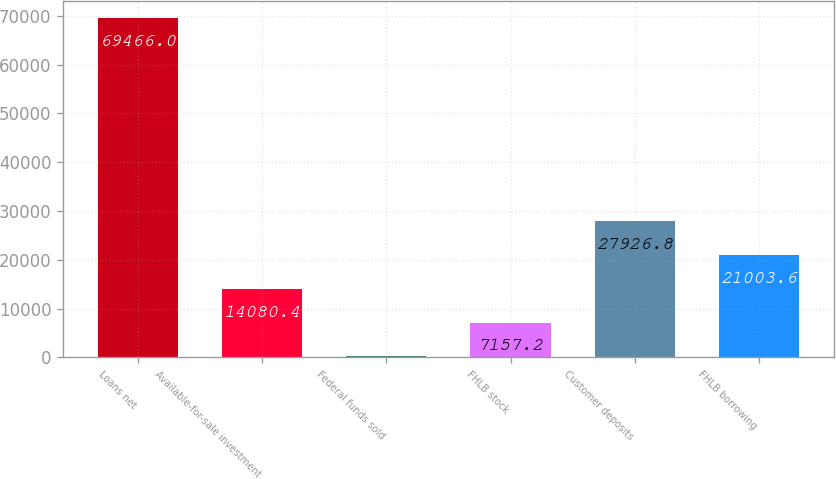<chart> <loc_0><loc_0><loc_500><loc_500><bar_chart><fcel>Loans net<fcel>Available-for-sale investment<fcel>Federal funds sold<fcel>FHLB stock<fcel>Customer deposits<fcel>FHLB borrowing<nl><fcel>69466<fcel>14080.4<fcel>234<fcel>7157.2<fcel>27926.8<fcel>21003.6<nl></chart> 